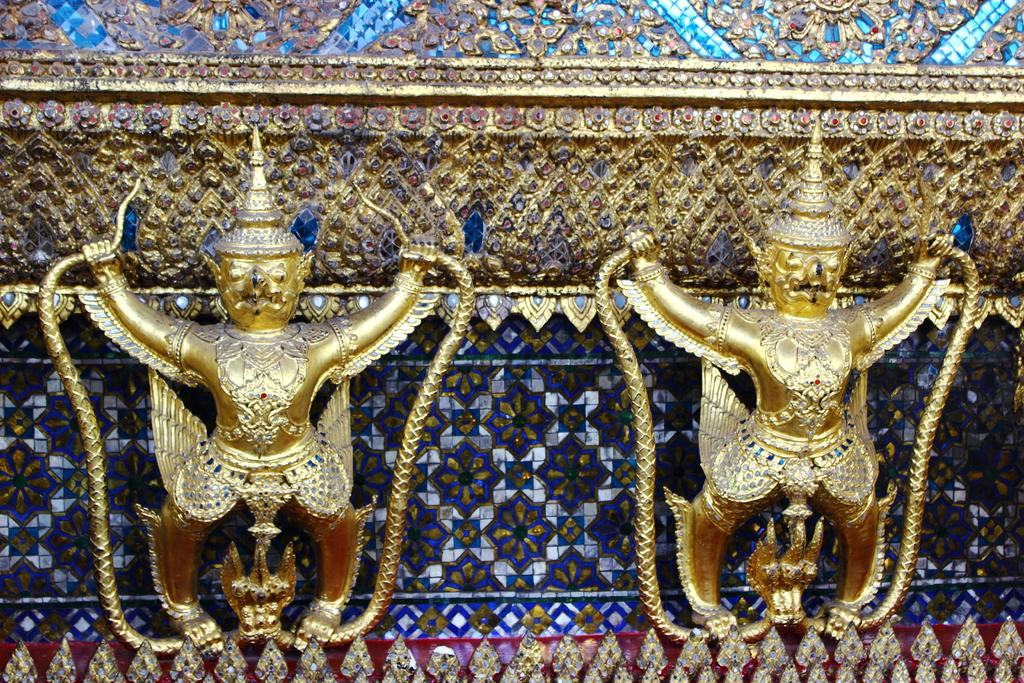How many sculptures are in the image? There are two sculptures in the image. Where are the sculptures located? The sculptures are standing on a platform. What are the sculptures holding? The sculptures are holding an object. Can you describe the background of the image? There is an object visible in the background of the image. What type of food is the boy eating in the image? There is no boy present in the image, and therefore no such activity can be observed. 